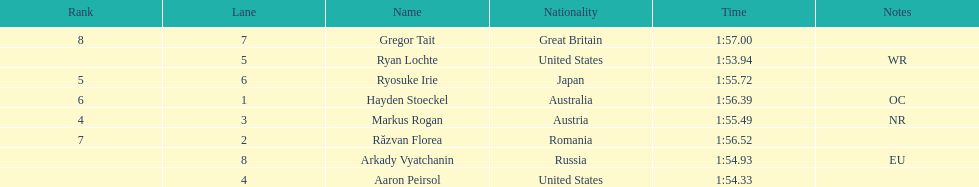Which competitor was the last to place? Gregor Tait. Write the full table. {'header': ['Rank', 'Lane', 'Name', 'Nationality', 'Time', 'Notes'], 'rows': [['8', '7', 'Gregor Tait', 'Great Britain', '1:57.00', ''], ['', '5', 'Ryan Lochte', 'United States', '1:53.94', 'WR'], ['5', '6', 'Ryosuke Irie', 'Japan', '1:55.72', ''], ['6', '1', 'Hayden Stoeckel', 'Australia', '1:56.39', 'OC'], ['4', '3', 'Markus Rogan', 'Austria', '1:55.49', 'NR'], ['7', '2', 'Răzvan Florea', 'Romania', '1:56.52', ''], ['', '8', 'Arkady Vyatchanin', 'Russia', '1:54.93', 'EU'], ['', '4', 'Aaron Peirsol', 'United States', '1:54.33', '']]} 